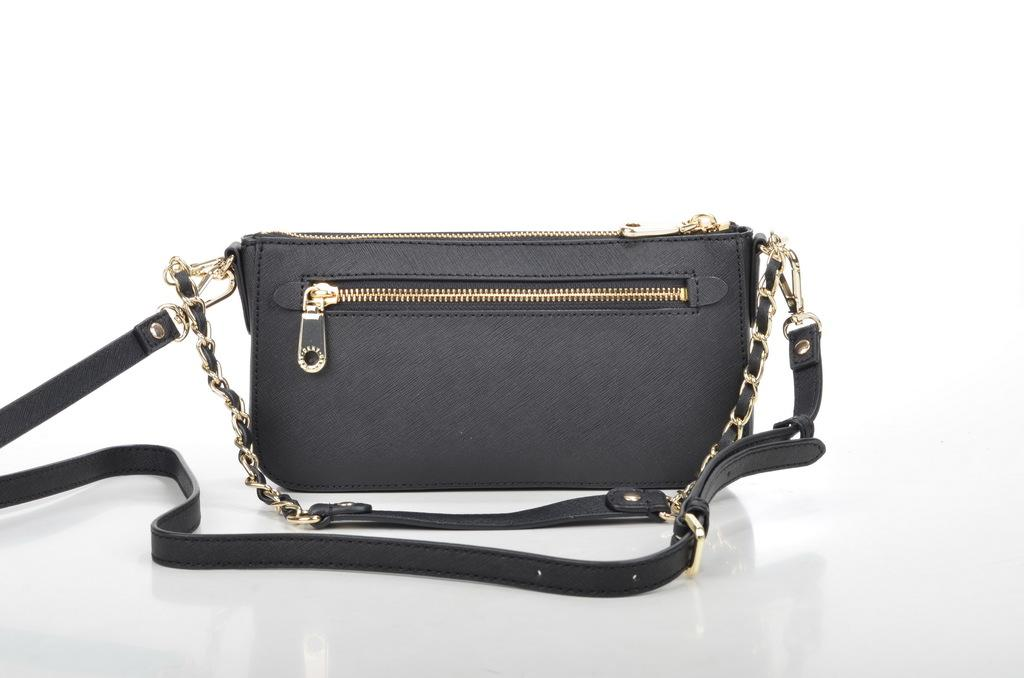What is the color of the bag in the image? The bag in the image is black. What is attached to the bag? The bag has a chain attached to it. What design is featured on the jar in the image? There is no jar present in the image; it only features a black color bag with a chain attached to it. 